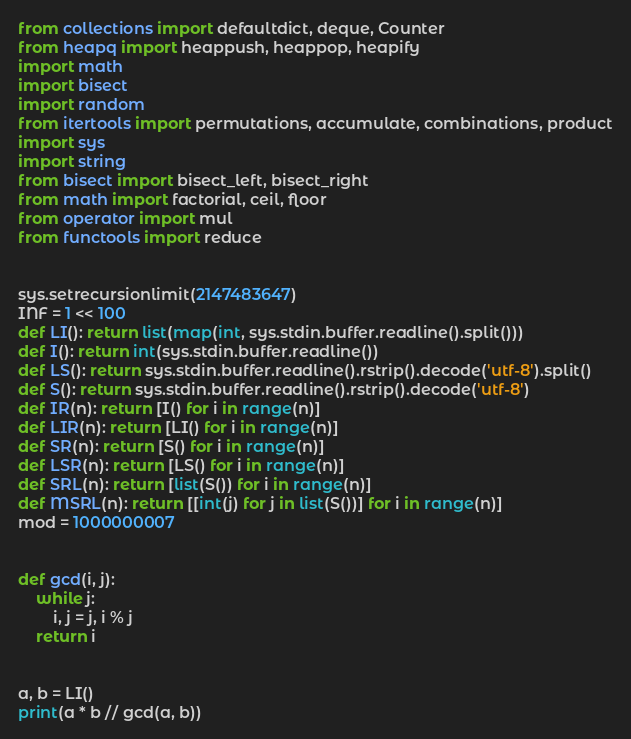<code> <loc_0><loc_0><loc_500><loc_500><_Python_>from collections import defaultdict, deque, Counter
from heapq import heappush, heappop, heapify
import math
import bisect
import random
from itertools import permutations, accumulate, combinations, product
import sys
import string
from bisect import bisect_left, bisect_right
from math import factorial, ceil, floor
from operator import mul
from functools import reduce


sys.setrecursionlimit(2147483647)
INF = 1 << 100
def LI(): return list(map(int, sys.stdin.buffer.readline().split()))
def I(): return int(sys.stdin.buffer.readline())
def LS(): return sys.stdin.buffer.readline().rstrip().decode('utf-8').split()
def S(): return sys.stdin.buffer.readline().rstrip().decode('utf-8')
def IR(n): return [I() for i in range(n)]
def LIR(n): return [LI() for i in range(n)]
def SR(n): return [S() for i in range(n)]
def LSR(n): return [LS() for i in range(n)]
def SRL(n): return [list(S()) for i in range(n)]
def MSRL(n): return [[int(j) for j in list(S())] for i in range(n)]
mod = 1000000007


def gcd(i, j):
    while j:
        i, j = j, i % j
    return i


a, b = LI()
print(a * b // gcd(a, b))</code> 